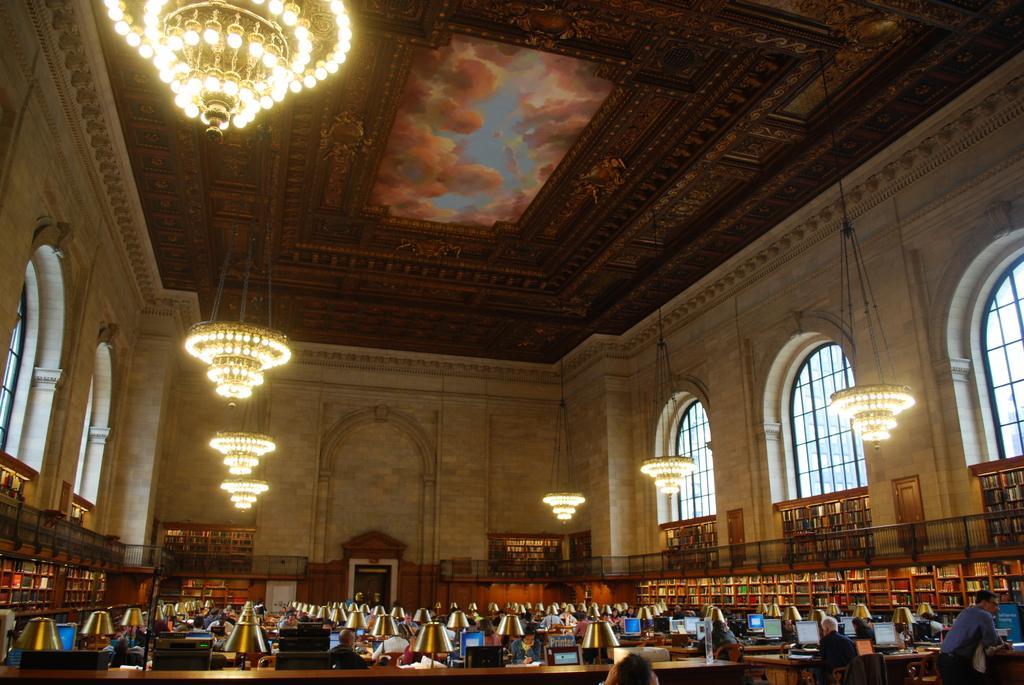Please provide a concise description of this image. In this picture I can see group of people sitting on the chairs, there are lamps, monitors and some other objects on the tables, there are books in the racks, there are windows and there are chandeliers hanging to the ceiling. 